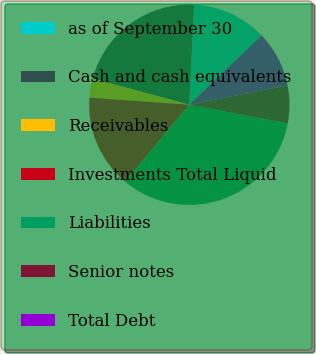Convert chart to OTSL. <chart><loc_0><loc_0><loc_500><loc_500><pie_chart><fcel>as of September 30<fcel>Cash and cash equivalents<fcel>Receivables<fcel>Investments Total Liquid<fcel>Liabilities<fcel>Senior notes<fcel>Total Debt<nl><fcel>12.07%<fcel>21.56%<fcel>3.07%<fcel>15.07%<fcel>33.08%<fcel>6.07%<fcel>9.07%<nl></chart> 